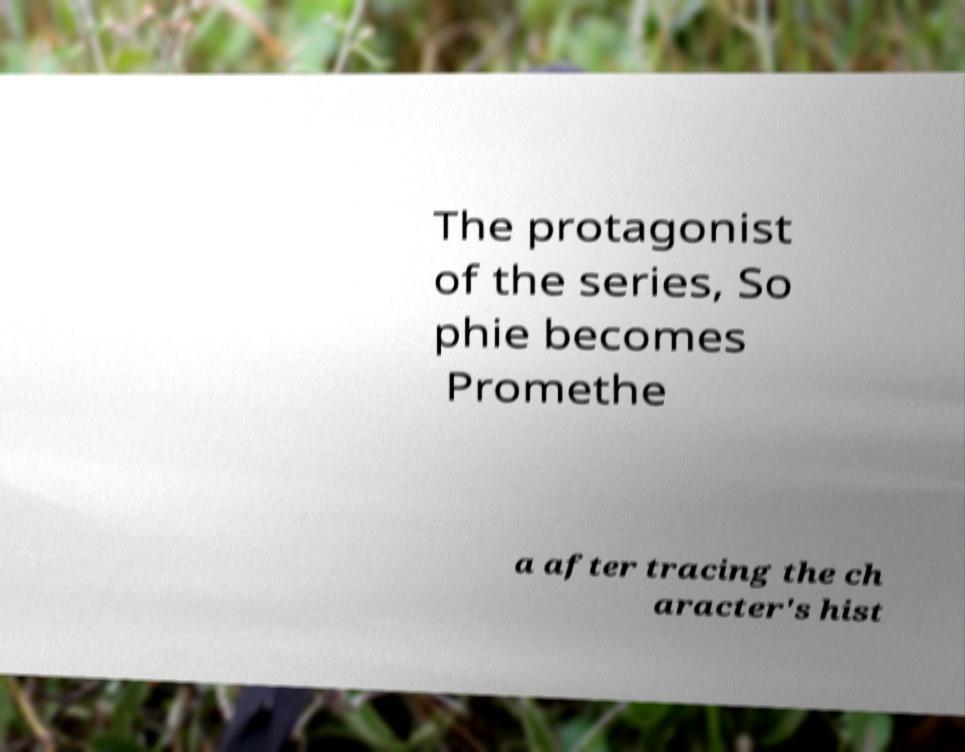I need the written content from this picture converted into text. Can you do that? The protagonist of the series, So phie becomes Promethe a after tracing the ch aracter's hist 